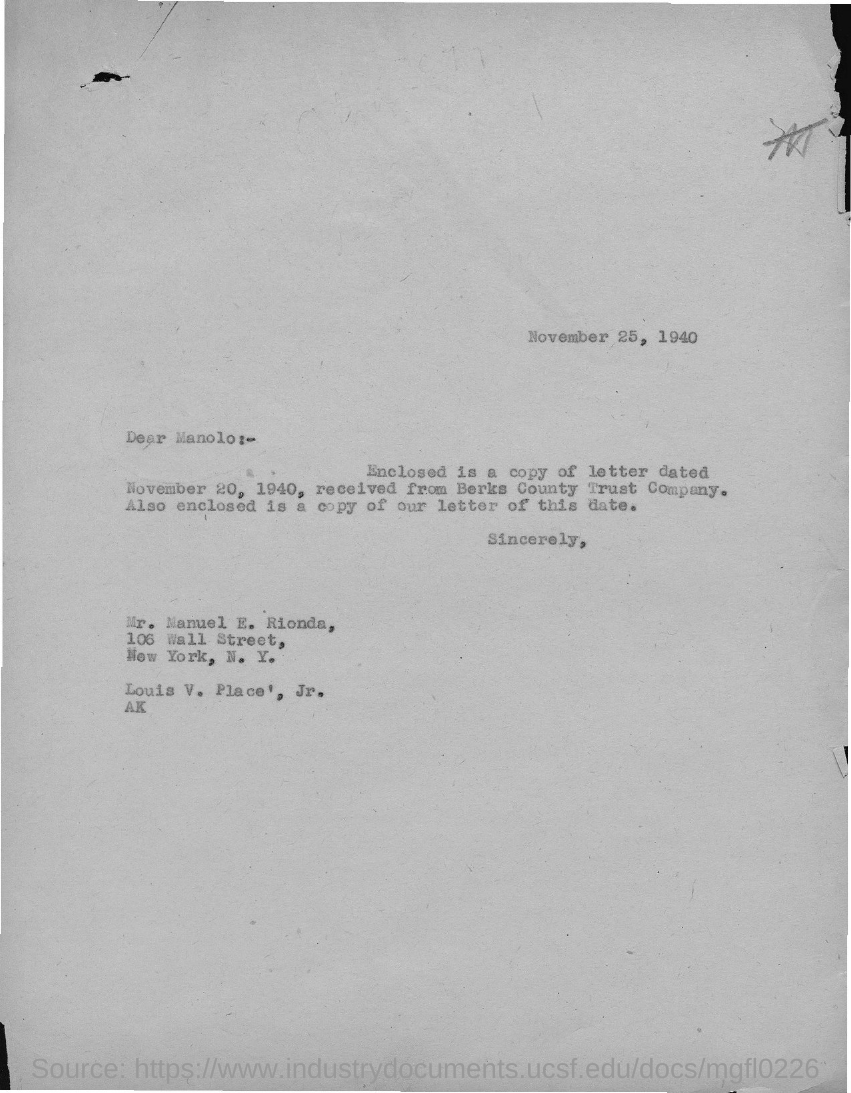Indicate a few pertinent items in this graphic. The document indicates that the date is November 25, 1940. 